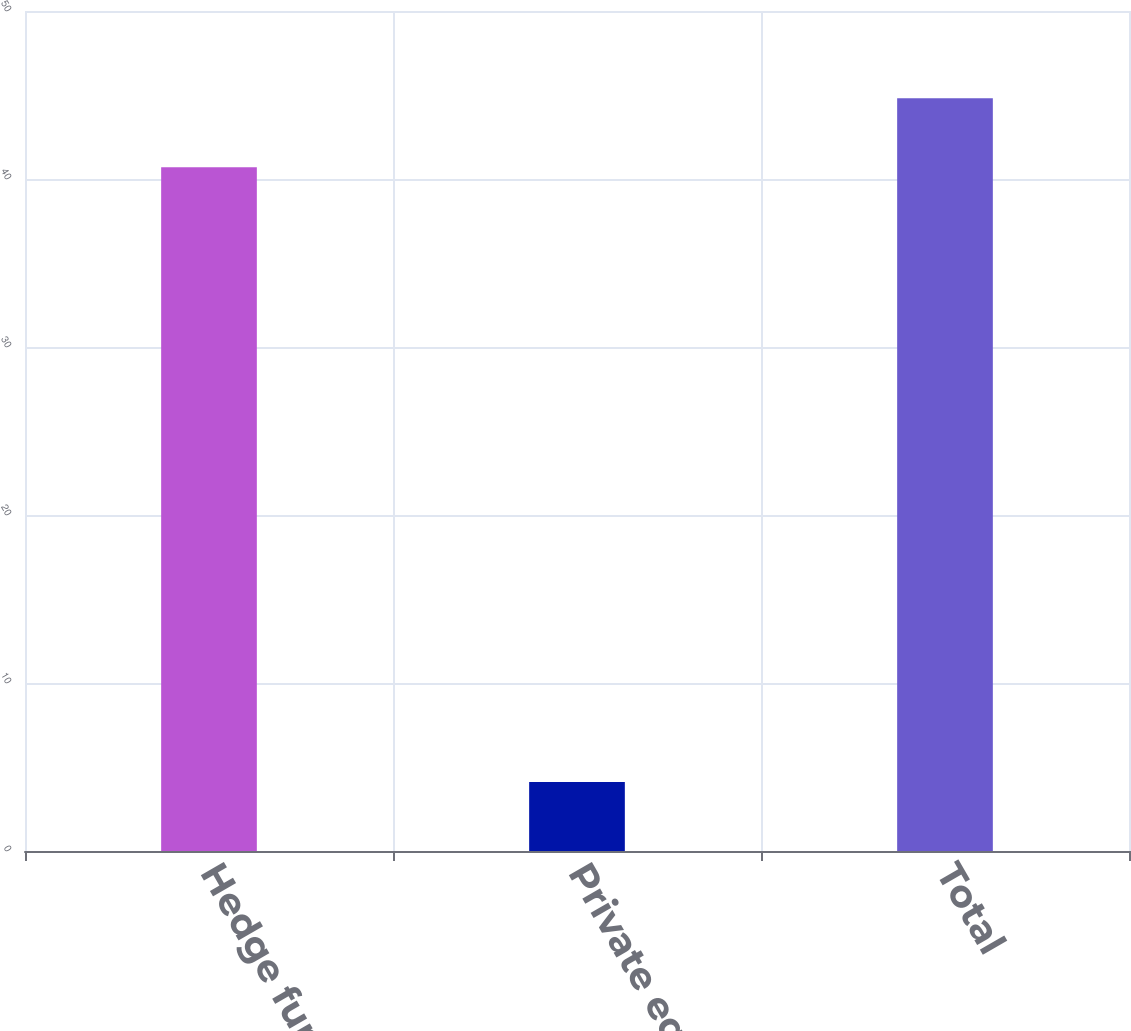Convert chart. <chart><loc_0><loc_0><loc_500><loc_500><bar_chart><fcel>Hedge funds<fcel>Private equity funds<fcel>Total<nl><fcel>40.7<fcel>4.1<fcel>44.8<nl></chart> 